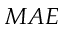<formula> <loc_0><loc_0><loc_500><loc_500>M A E</formula> 